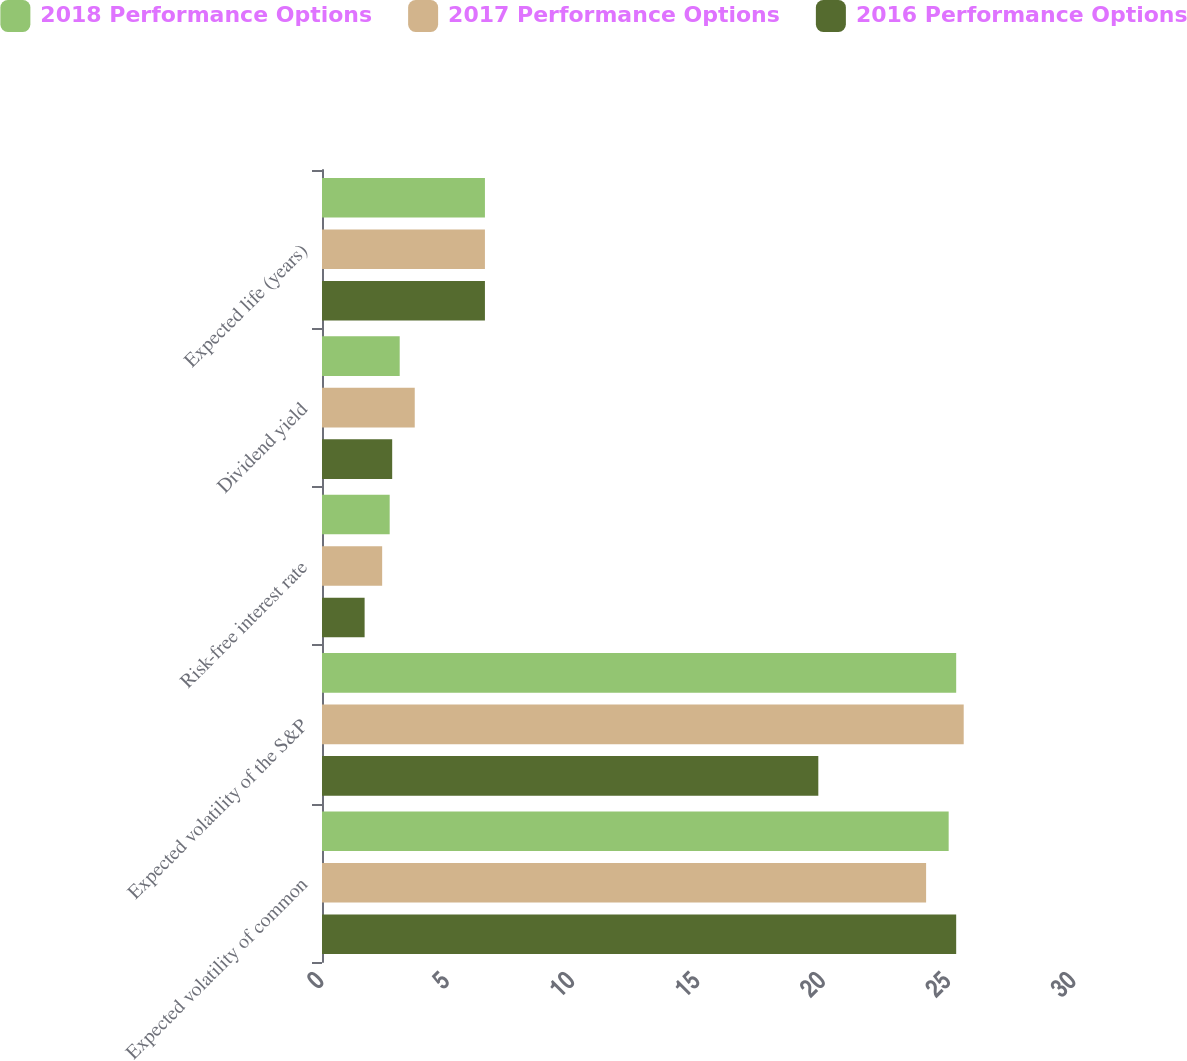Convert chart. <chart><loc_0><loc_0><loc_500><loc_500><stacked_bar_chart><ecel><fcel>Expected volatility of common<fcel>Expected volatility of the S&P<fcel>Risk-free interest rate<fcel>Dividend yield<fcel>Expected life (years)<nl><fcel>2018 Performance Options<fcel>25<fcel>25.3<fcel>2.7<fcel>3.1<fcel>6.5<nl><fcel>2017 Performance Options<fcel>24.1<fcel>25.6<fcel>2.4<fcel>3.7<fcel>6.5<nl><fcel>2016 Performance Options<fcel>25.3<fcel>19.8<fcel>1.7<fcel>2.8<fcel>6.5<nl></chart> 